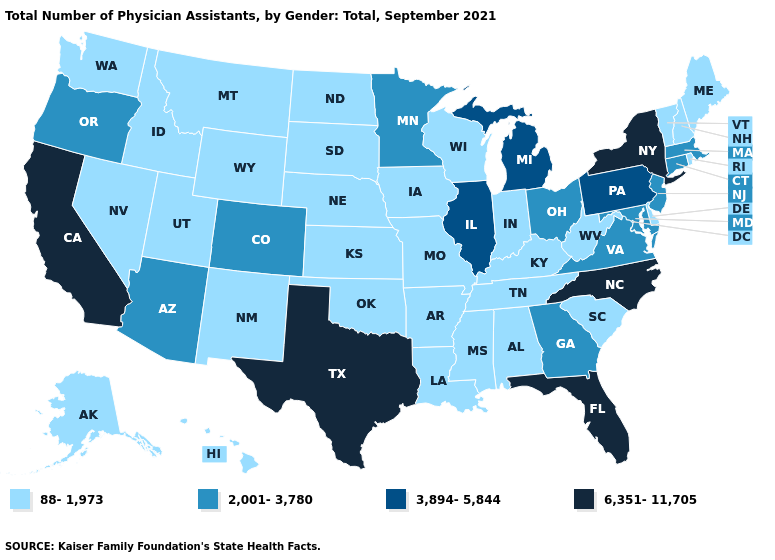Does Florida have the highest value in the USA?
Be succinct. Yes. Does Pennsylvania have the highest value in the Northeast?
Be succinct. No. Among the states that border New Jersey , does New York have the highest value?
Concise answer only. Yes. Among the states that border Tennessee , does North Carolina have the highest value?
Concise answer only. Yes. What is the value of Michigan?
Keep it brief. 3,894-5,844. Is the legend a continuous bar?
Be succinct. No. What is the highest value in states that border Michigan?
Concise answer only. 2,001-3,780. Does Connecticut have a lower value than Iowa?
Short answer required. No. What is the value of Massachusetts?
Write a very short answer. 2,001-3,780. What is the value of Virginia?
Be succinct. 2,001-3,780. Name the states that have a value in the range 6,351-11,705?
Short answer required. California, Florida, New York, North Carolina, Texas. Among the states that border Indiana , does Illinois have the highest value?
Keep it brief. Yes. Does Georgia have the lowest value in the South?
Give a very brief answer. No. Which states hav the highest value in the Northeast?
Write a very short answer. New York. Name the states that have a value in the range 6,351-11,705?
Be succinct. California, Florida, New York, North Carolina, Texas. 